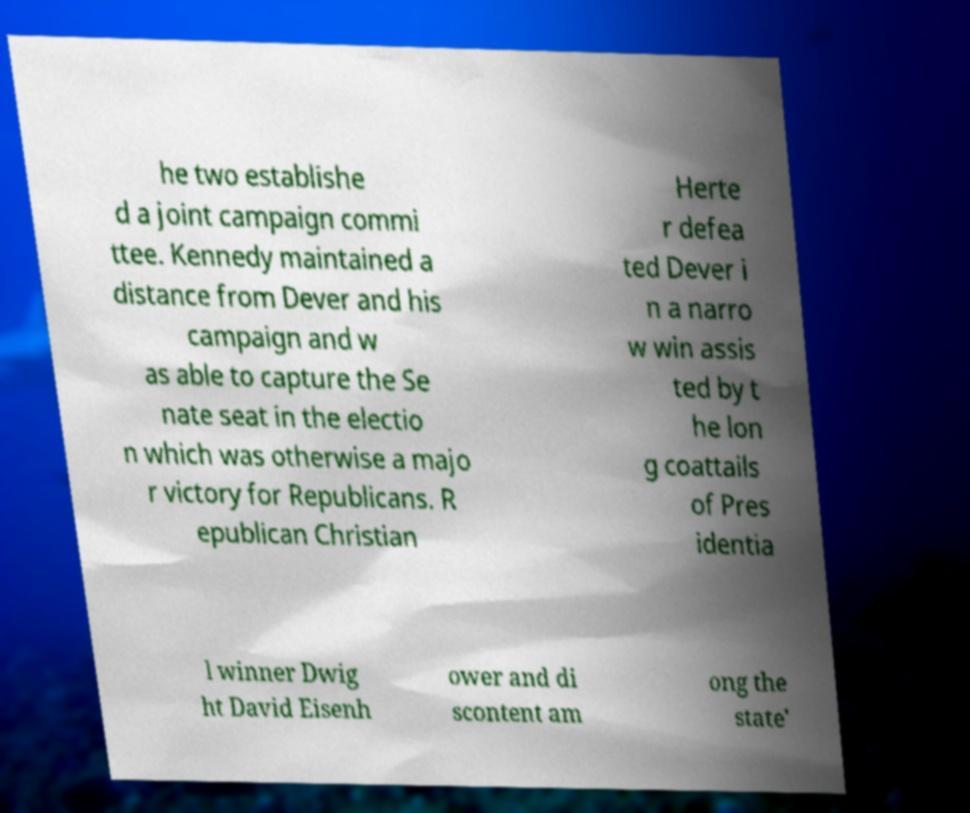What messages or text are displayed in this image? I need them in a readable, typed format. he two establishe d a joint campaign commi ttee. Kennedy maintained a distance from Dever and his campaign and w as able to capture the Se nate seat in the electio n which was otherwise a majo r victory for Republicans. R epublican Christian Herte r defea ted Dever i n a narro w win assis ted by t he lon g coattails of Pres identia l winner Dwig ht David Eisenh ower and di scontent am ong the state' 